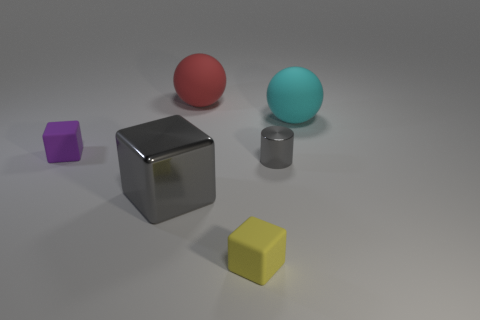Add 1 large gray metal blocks. How many objects exist? 7 Subtract all spheres. How many objects are left? 4 Subtract 0 brown cylinders. How many objects are left? 6 Subtract all big cyan matte balls. Subtract all blocks. How many objects are left? 2 Add 3 yellow rubber things. How many yellow rubber things are left? 4 Add 5 big balls. How many big balls exist? 7 